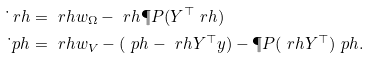Convert formula to latex. <formula><loc_0><loc_0><loc_500><loc_500>\dot { \ } r h & = \ r h w _ { \Omega } - \ r h \P P ( Y ^ { \top } \ r h ) \\ \dot { \ } p h & = \ r h w _ { V } - ( \ p h - \ r h Y ^ { \top } y ) - \P P ( \ r h Y ^ { \top } ) \ p h .</formula> 